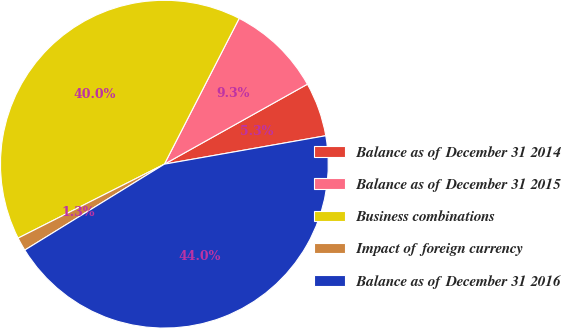<chart> <loc_0><loc_0><loc_500><loc_500><pie_chart><fcel>Balance as of December 31 2014<fcel>Balance as of December 31 2015<fcel>Business combinations<fcel>Impact of foreign currency<fcel>Balance as of December 31 2016<nl><fcel>5.34%<fcel>9.34%<fcel>40.0%<fcel>1.33%<fcel>44.0%<nl></chart> 